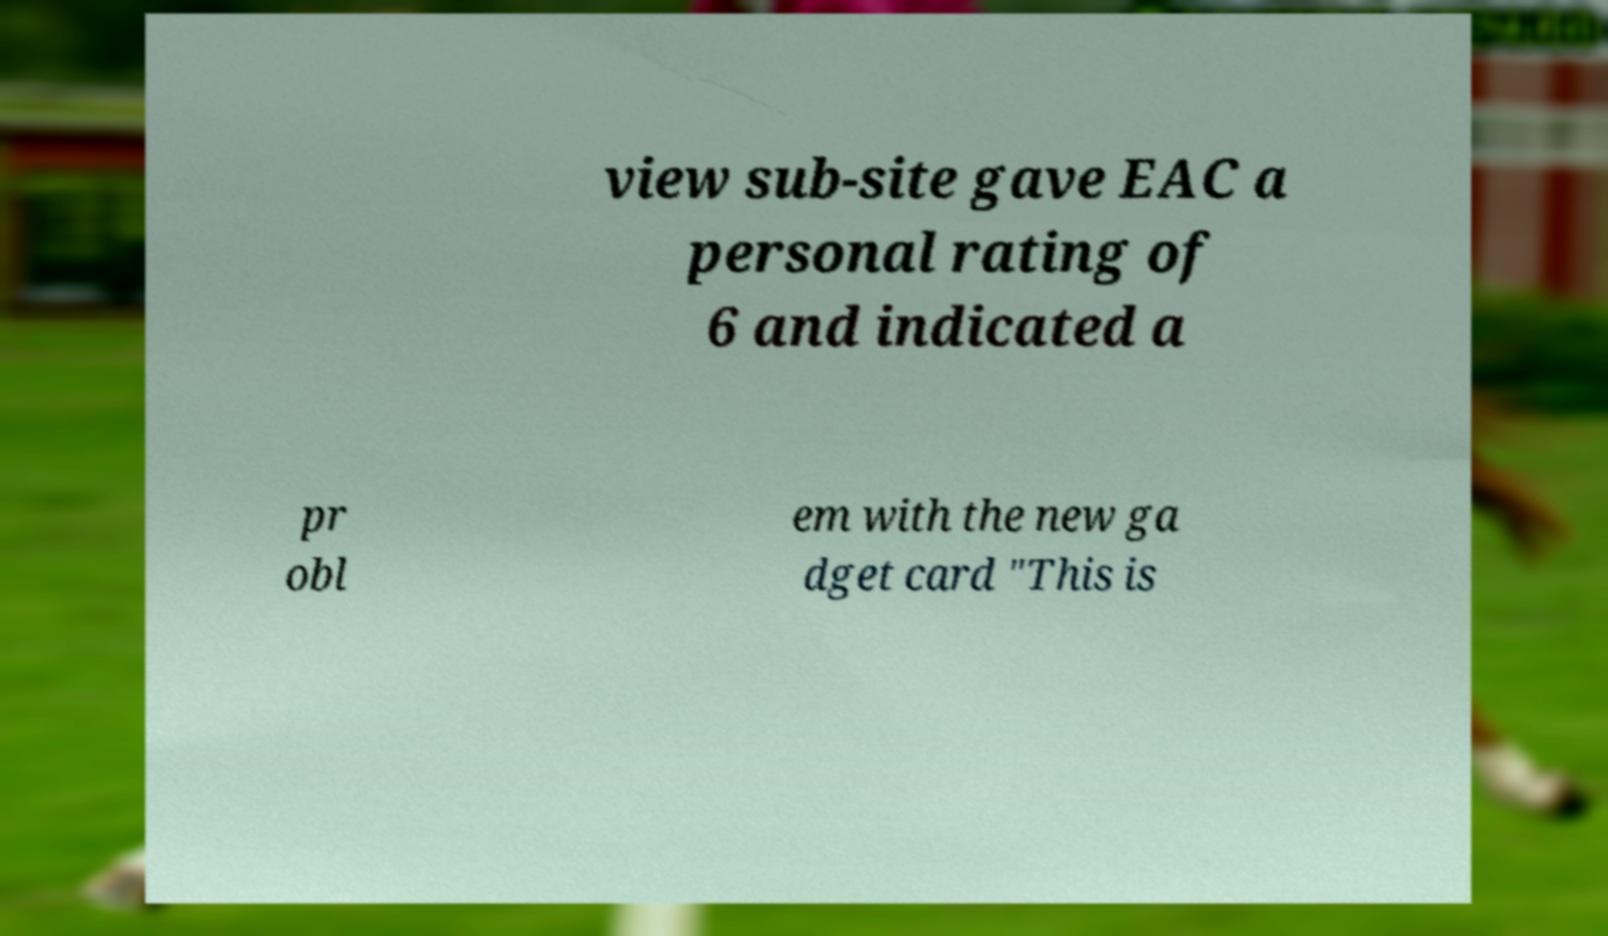Could you assist in decoding the text presented in this image and type it out clearly? view sub-site gave EAC a personal rating of 6 and indicated a pr obl em with the new ga dget card "This is 